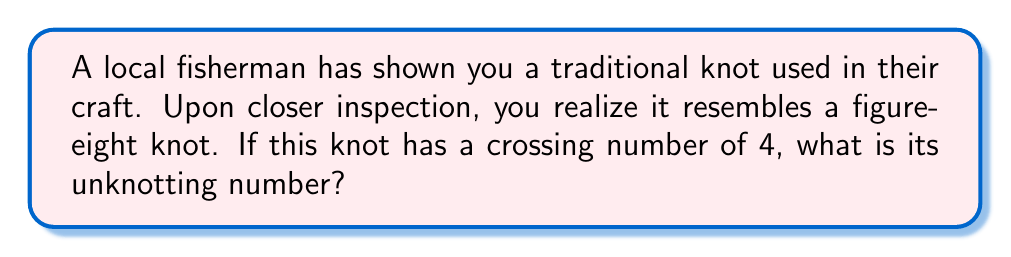Show me your answer to this math problem. To determine the unknotting number of the traditional fisherman's knot, we'll follow these steps:

1) First, recall that the unknotting number of a knot is the minimum number of crossing changes needed to transform the knot into an unknot (trivial knot).

2) For the figure-eight knot, which has a crossing number of 4, we can visualize it as:

[asy]
import geometry;

pair A=(0,0), B=(1,0), C=(0,1), D=(1,1);
draw(A--B--D--C--cycle);
draw(A--D);
draw(B--C);
dot(A); dot(B); dot(C); dot(D);
label("1", (0.5,-0.1));
label("2", (1.1,0.5));
label("3", (0.5,1.1));
label("4", (-0.1,0.5));
[/asy]

3) The unknotting number of the figure-eight knot is known to be 1. This means we only need to change one crossing to unknot it.

4) To verify this, we can change any one of the crossings (say, crossing 1) from an overcrossing to an undercrossing or vice versa:

[asy]
import geometry;

pair A=(0,0), B=(1,0), C=(0,1), D=(1,1);
draw(A--B--D--C--cycle);
draw(D--A);
draw(B--C);
dot(A); dot(B); dot(C); dot(D);
label("1", (0.5,-0.1));
label("2", (1.1,0.5));
label("3", (0.5,1.1));
label("4", (-0.1,0.5));
[/asy]

5) After this change, the knot can be deformed into a simple loop, which is the unknot.

6) Therefore, the unknotting number of this traditional fisherman's knot, which resembles a figure-eight knot, is 1.
Answer: 1 